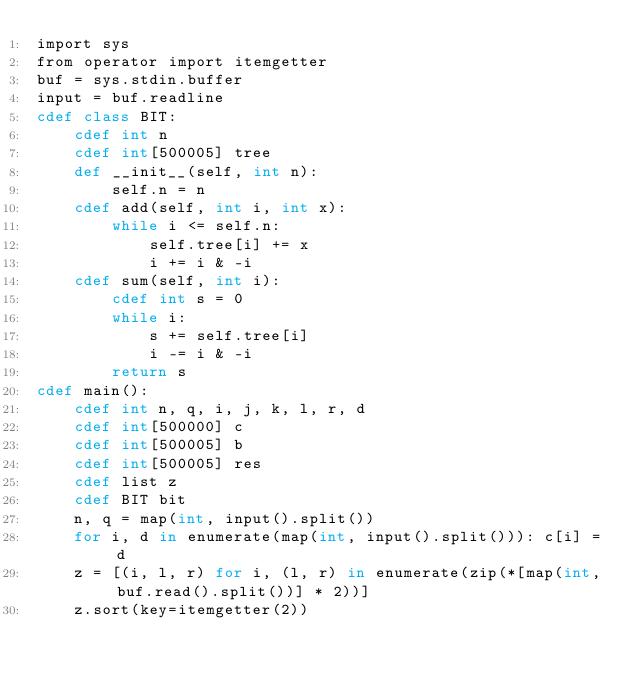Convert code to text. <code><loc_0><loc_0><loc_500><loc_500><_Cython_>import sys
from operator import itemgetter
buf = sys.stdin.buffer
input = buf.readline
cdef class BIT:
    cdef int n
    cdef int[500005] tree
    def __init__(self, int n):
        self.n = n
    cdef add(self, int i, int x):
        while i <= self.n:
            self.tree[i] += x
            i += i & -i
    cdef sum(self, int i):
        cdef int s = 0
        while i:
            s += self.tree[i]
            i -= i & -i
        return s
cdef main():
    cdef int n, q, i, j, k, l, r, d
    cdef int[500000] c
    cdef int[500005] b
    cdef int[500005] res
    cdef list z
    cdef BIT bit
    n, q = map(int, input().split())
    for i, d in enumerate(map(int, input().split())): c[i] = d
    z = [(i, l, r) for i, (l, r) in enumerate(zip(*[map(int, buf.read().split())] * 2))]
    z.sort(key=itemgetter(2))</code> 